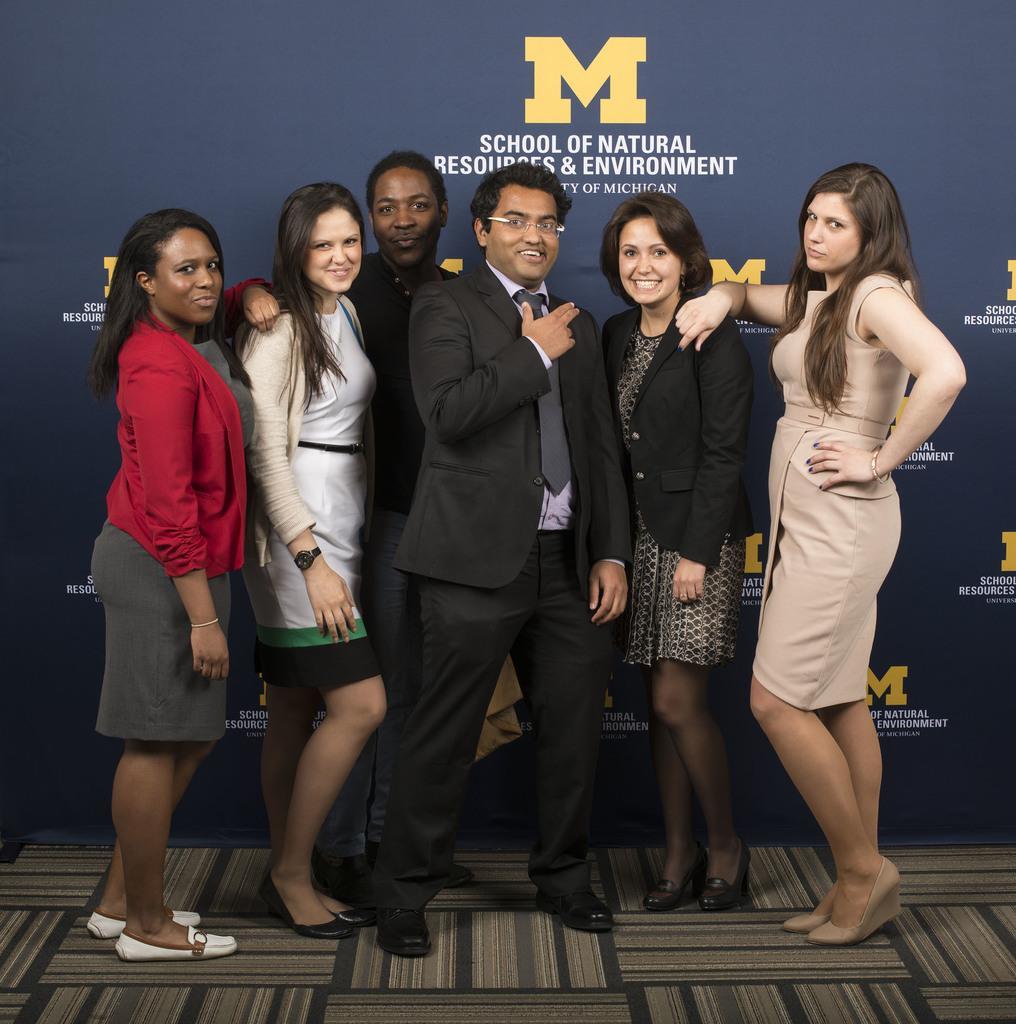How would you summarize this image in a sentence or two? In front of the image there are a few people standing on the mat and they are having a smile on their faces. Behind them there is a banner with some text on it. 